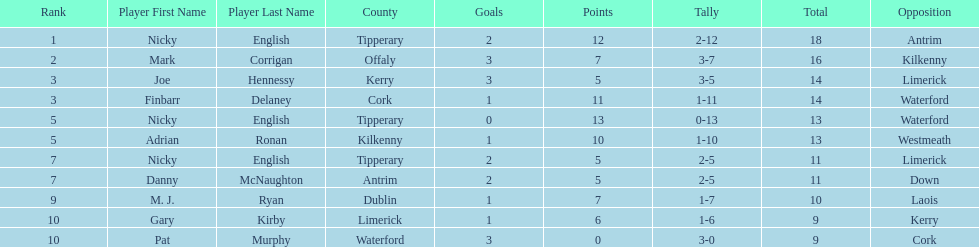What player got 10 total points in their game? M. J. Ryan. 